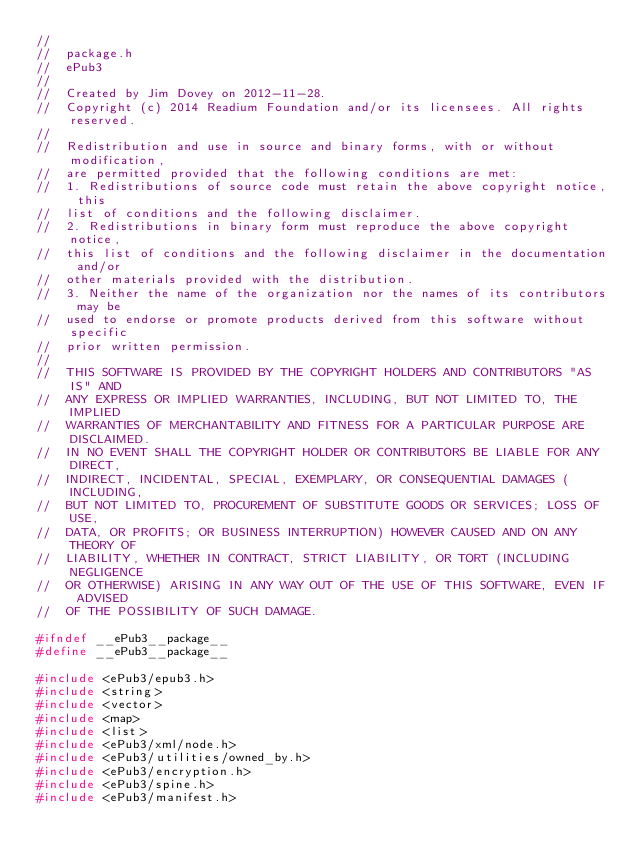Convert code to text. <code><loc_0><loc_0><loc_500><loc_500><_C_>//
//  package.h
//  ePub3
//
//  Created by Jim Dovey on 2012-11-28.
//  Copyright (c) 2014 Readium Foundation and/or its licensees. All rights reserved.
//  
//  Redistribution and use in source and binary forms, with or without modification, 
//  are permitted provided that the following conditions are met:
//  1. Redistributions of source code must retain the above copyright notice, this 
//  list of conditions and the following disclaimer.
//  2. Redistributions in binary form must reproduce the above copyright notice, 
//  this list of conditions and the following disclaimer in the documentation and/or 
//  other materials provided with the distribution.
//  3. Neither the name of the organization nor the names of its contributors may be 
//  used to endorse or promote products derived from this software without specific 
//  prior written permission.
//  
//  THIS SOFTWARE IS PROVIDED BY THE COPYRIGHT HOLDERS AND CONTRIBUTORS "AS IS" AND 
//  ANY EXPRESS OR IMPLIED WARRANTIES, INCLUDING, BUT NOT LIMITED TO, THE IMPLIED 
//  WARRANTIES OF MERCHANTABILITY AND FITNESS FOR A PARTICULAR PURPOSE ARE DISCLAIMED. 
//  IN NO EVENT SHALL THE COPYRIGHT HOLDER OR CONTRIBUTORS BE LIABLE FOR ANY DIRECT, 
//  INDIRECT, INCIDENTAL, SPECIAL, EXEMPLARY, OR CONSEQUENTIAL DAMAGES (INCLUDING, 
//  BUT NOT LIMITED TO, PROCUREMENT OF SUBSTITUTE GOODS OR SERVICES; LOSS OF USE, 
//  DATA, OR PROFITS; OR BUSINESS INTERRUPTION) HOWEVER CAUSED AND ON ANY THEORY OF 
//  LIABILITY, WHETHER IN CONTRACT, STRICT LIABILITY, OR TORT (INCLUDING NEGLIGENCE 
//  OR OTHERWISE) ARISING IN ANY WAY OUT OF THE USE OF THIS SOFTWARE, EVEN IF ADVISED 
//  OF THE POSSIBILITY OF SUCH DAMAGE.

#ifndef __ePub3__package__
#define __ePub3__package__

#include <ePub3/epub3.h>
#include <string>
#include <vector>
#include <map>
#include <list>
#include <ePub3/xml/node.h>
#include <ePub3/utilities/owned_by.h>
#include <ePub3/encryption.h>
#include <ePub3/spine.h>
#include <ePub3/manifest.h></code> 